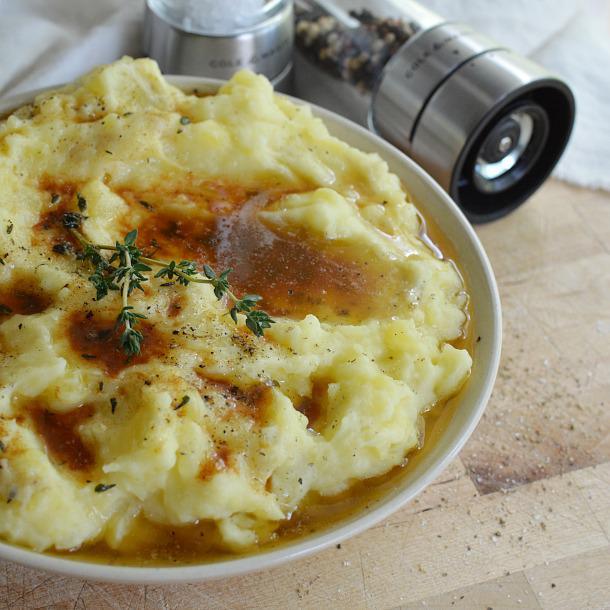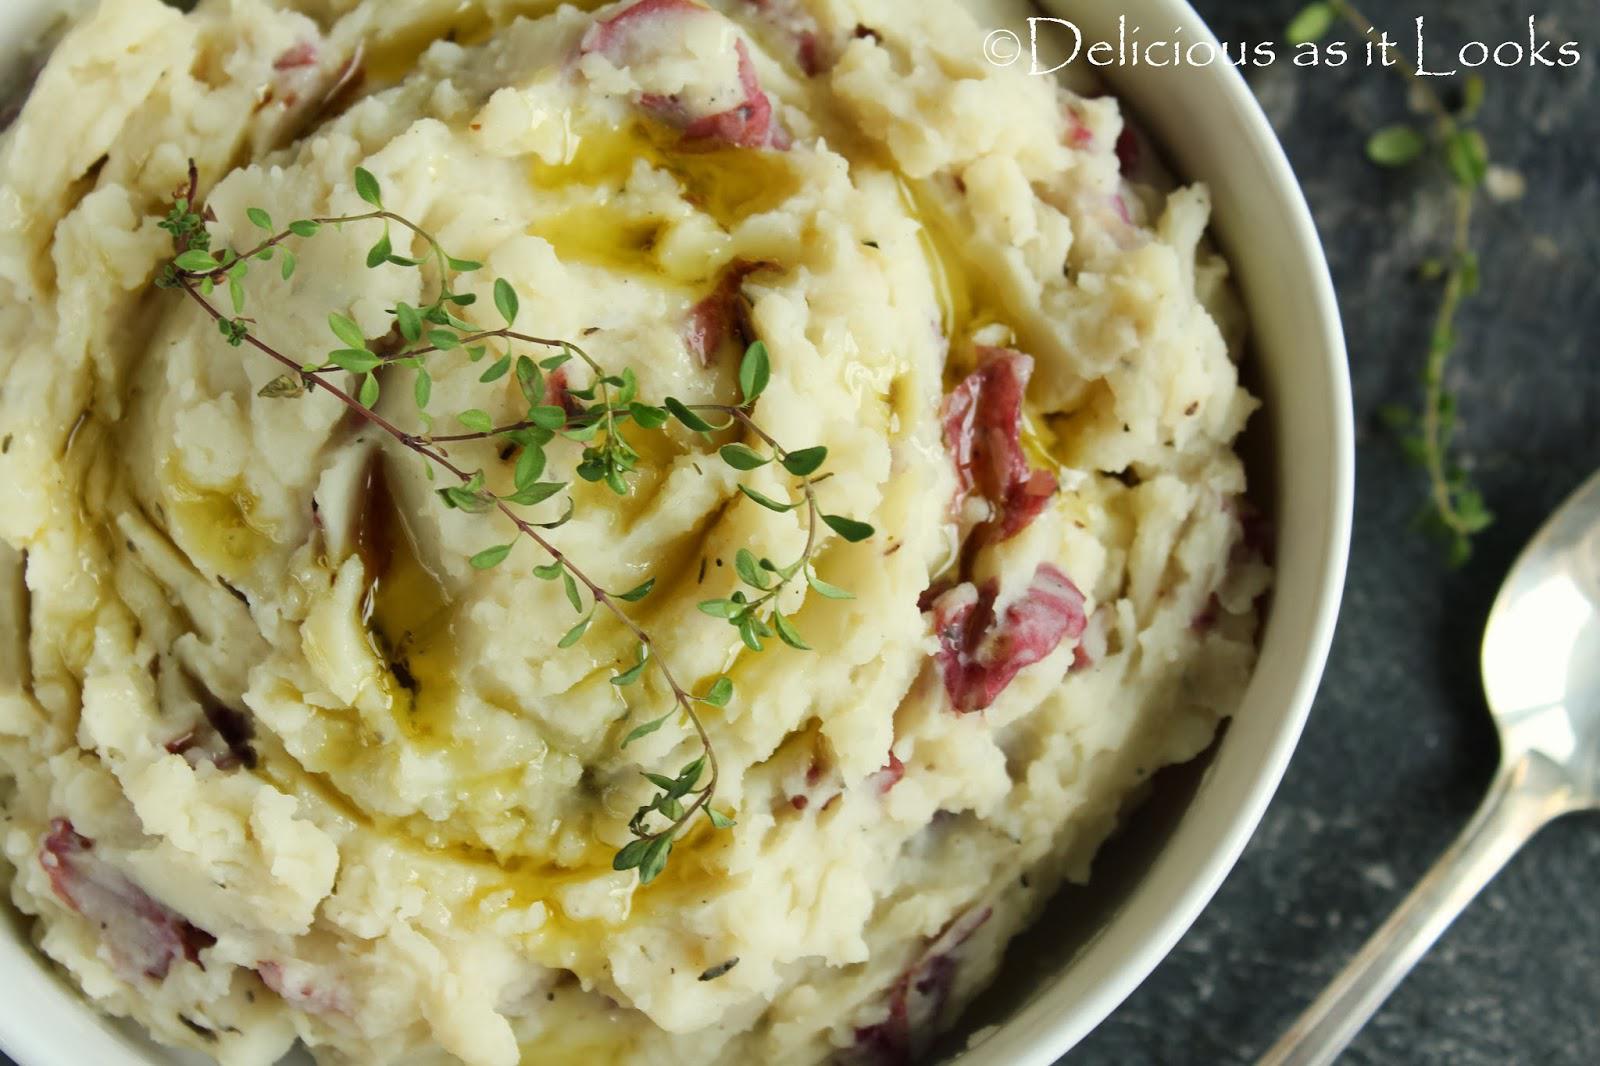The first image is the image on the left, the second image is the image on the right. Analyze the images presented: Is the assertion "Each image shows mashed potatoes on a round white dish, at least one image shows brown broth over the potatoes, and a piece of silverware is to the right of one dish." valid? Answer yes or no. Yes. The first image is the image on the left, the second image is the image on the right. For the images displayed, is the sentence "In one image, brown gravy and a spring of chive are on mashed potatoes in a white bowl." factually correct? Answer yes or no. Yes. 